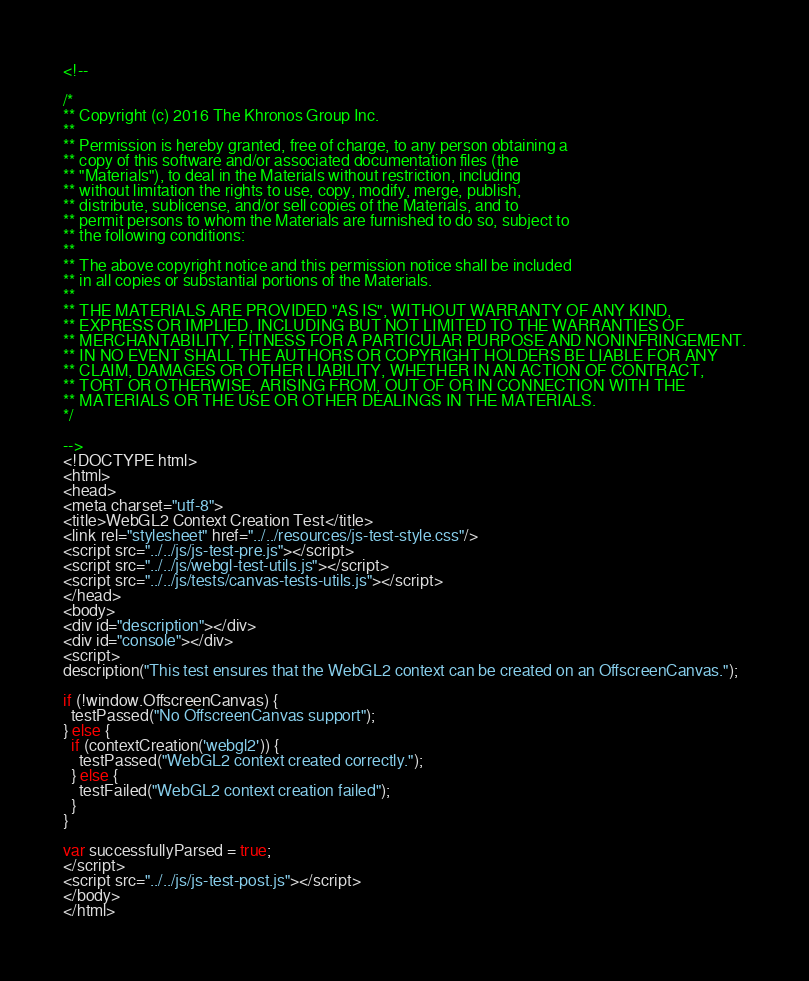<code> <loc_0><loc_0><loc_500><loc_500><_HTML_><!--

/*
** Copyright (c) 2016 The Khronos Group Inc.
**
** Permission is hereby granted, free of charge, to any person obtaining a
** copy of this software and/or associated documentation files (the
** "Materials"), to deal in the Materials without restriction, including
** without limitation the rights to use, copy, modify, merge, publish,
** distribute, sublicense, and/or sell copies of the Materials, and to
** permit persons to whom the Materials are furnished to do so, subject to
** the following conditions:
**
** The above copyright notice and this permission notice shall be included
** in all copies or substantial portions of the Materials.
**
** THE MATERIALS ARE PROVIDED "AS IS", WITHOUT WARRANTY OF ANY KIND,
** EXPRESS OR IMPLIED, INCLUDING BUT NOT LIMITED TO THE WARRANTIES OF
** MERCHANTABILITY, FITNESS FOR A PARTICULAR PURPOSE AND NONINFRINGEMENT.
** IN NO EVENT SHALL THE AUTHORS OR COPYRIGHT HOLDERS BE LIABLE FOR ANY
** CLAIM, DAMAGES OR OTHER LIABILITY, WHETHER IN AN ACTION OF CONTRACT,
** TORT OR OTHERWISE, ARISING FROM, OUT OF OR IN CONNECTION WITH THE
** MATERIALS OR THE USE OR OTHER DEALINGS IN THE MATERIALS.
*/

-->
<!DOCTYPE html>
<html>
<head>
<meta charset="utf-8">
<title>WebGL2 Context Creation Test</title>
<link rel="stylesheet" href="../../resources/js-test-style.css"/>
<script src="../../js/js-test-pre.js"></script>
<script src="../../js/webgl-test-utils.js"></script>
<script src="../../js/tests/canvas-tests-utils.js"></script>
</head>
<body>
<div id="description"></div>
<div id="console"></div>
<script>
description("This test ensures that the WebGL2 context can be created on an OffscreenCanvas.");

if (!window.OffscreenCanvas) {
  testPassed("No OffscreenCanvas support");
} else {
  if (contextCreation('webgl2')) {
    testPassed("WebGL2 context created correctly.");
  } else {
    testFailed("WebGL2 context creation failed");
  }
}

var successfullyParsed = true;
</script>
<script src="../../js/js-test-post.js"></script>
</body>
</html>
</code> 